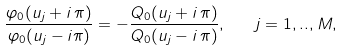Convert formula to latex. <formula><loc_0><loc_0><loc_500><loc_500>\frac { \varphi _ { 0 } ( u _ { j } + i \, \pi ) } { \varphi _ { 0 } ( u _ { j } - i \pi ) } = - \frac { Q _ { 0 } ( u _ { j } + i \, \pi ) } { Q _ { 0 } ( u _ { j } - i \, \pi ) } , \quad j = 1 , . . , M ,</formula> 